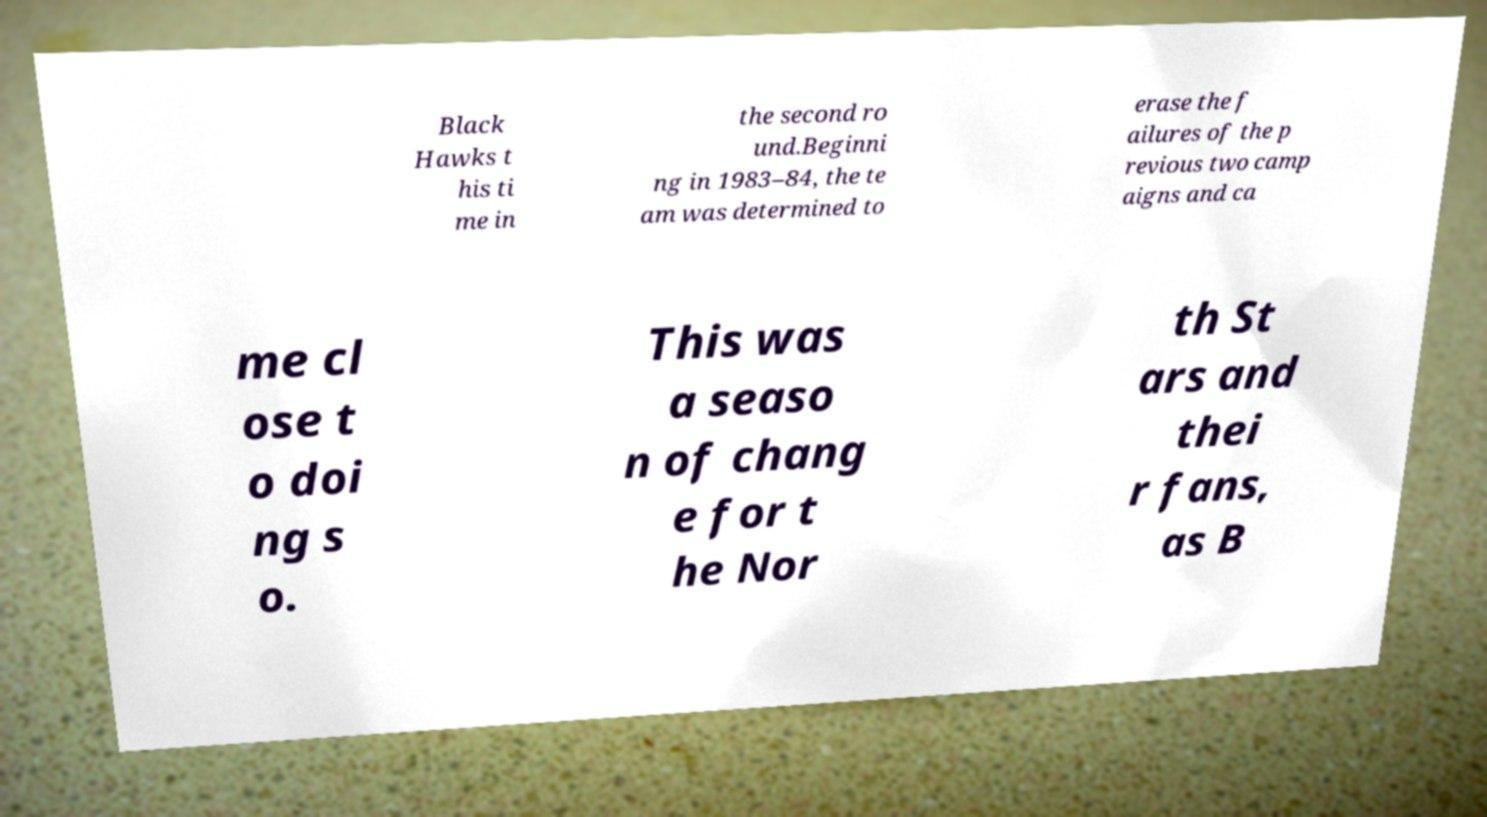What messages or text are displayed in this image? I need them in a readable, typed format. Black Hawks t his ti me in the second ro und.Beginni ng in 1983–84, the te am was determined to erase the f ailures of the p revious two camp aigns and ca me cl ose t o doi ng s o. This was a seaso n of chang e for t he Nor th St ars and thei r fans, as B 